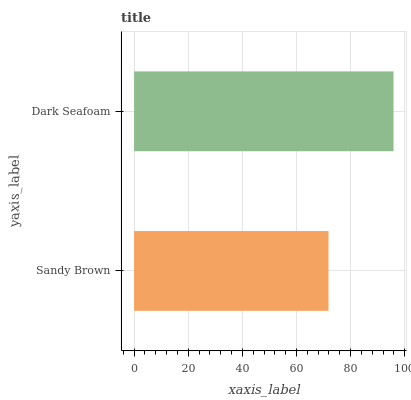Is Sandy Brown the minimum?
Answer yes or no. Yes. Is Dark Seafoam the maximum?
Answer yes or no. Yes. Is Dark Seafoam the minimum?
Answer yes or no. No. Is Dark Seafoam greater than Sandy Brown?
Answer yes or no. Yes. Is Sandy Brown less than Dark Seafoam?
Answer yes or no. Yes. Is Sandy Brown greater than Dark Seafoam?
Answer yes or no. No. Is Dark Seafoam less than Sandy Brown?
Answer yes or no. No. Is Dark Seafoam the high median?
Answer yes or no. Yes. Is Sandy Brown the low median?
Answer yes or no. Yes. Is Sandy Brown the high median?
Answer yes or no. No. Is Dark Seafoam the low median?
Answer yes or no. No. 